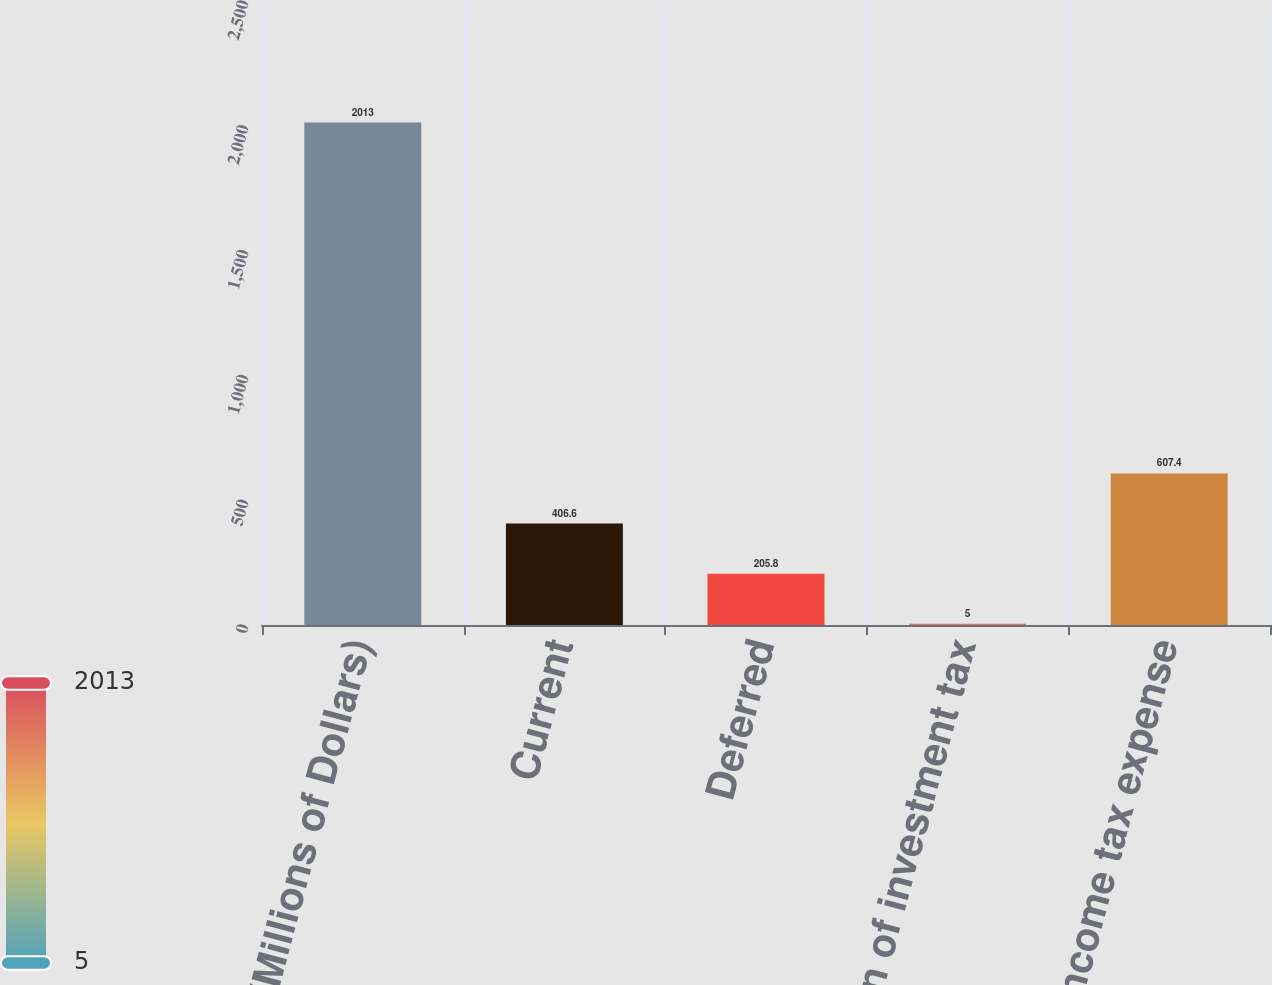<chart> <loc_0><loc_0><loc_500><loc_500><bar_chart><fcel>(Millions of Dollars)<fcel>Current<fcel>Deferred<fcel>Amortization of investment tax<fcel>Total income tax expense<nl><fcel>2013<fcel>406.6<fcel>205.8<fcel>5<fcel>607.4<nl></chart> 